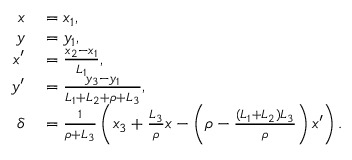<formula> <loc_0><loc_0><loc_500><loc_500>\begin{array} { r l } { x } & = x _ { 1 } , } \\ { y } & = y _ { 1 } , } \\ { x ^ { \prime } } & = \frac { x _ { 2 } - x _ { 1 } } { L _ { 1 } } , } \\ { y ^ { \prime } } & = \frac { y _ { 3 } - y _ { 1 } } { L _ { 1 } + L _ { 2 } + \rho + L _ { 3 } } , } \\ { \delta } & = \frac { 1 } { \rho + L _ { 3 } } \left ( x _ { 3 } + \frac { L _ { 3 } } { \rho } x - \left ( { \rho - \frac { ( L _ { 1 } + L _ { 2 } ) L _ { 3 } } { \rho } } \right ) x ^ { \prime } \right ) . } \end{array}</formula> 